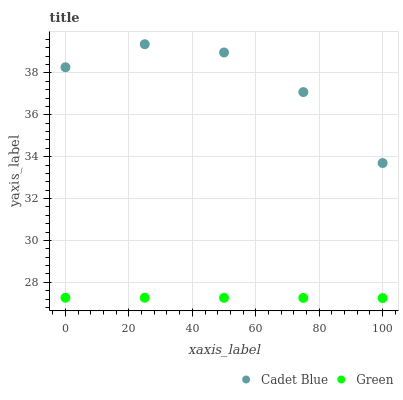Does Green have the minimum area under the curve?
Answer yes or no. Yes. Does Cadet Blue have the maximum area under the curve?
Answer yes or no. Yes. Does Green have the maximum area under the curve?
Answer yes or no. No. Is Green the smoothest?
Answer yes or no. Yes. Is Cadet Blue the roughest?
Answer yes or no. Yes. Is Green the roughest?
Answer yes or no. No. Does Green have the lowest value?
Answer yes or no. Yes. Does Cadet Blue have the highest value?
Answer yes or no. Yes. Does Green have the highest value?
Answer yes or no. No. Is Green less than Cadet Blue?
Answer yes or no. Yes. Is Cadet Blue greater than Green?
Answer yes or no. Yes. Does Green intersect Cadet Blue?
Answer yes or no. No. 